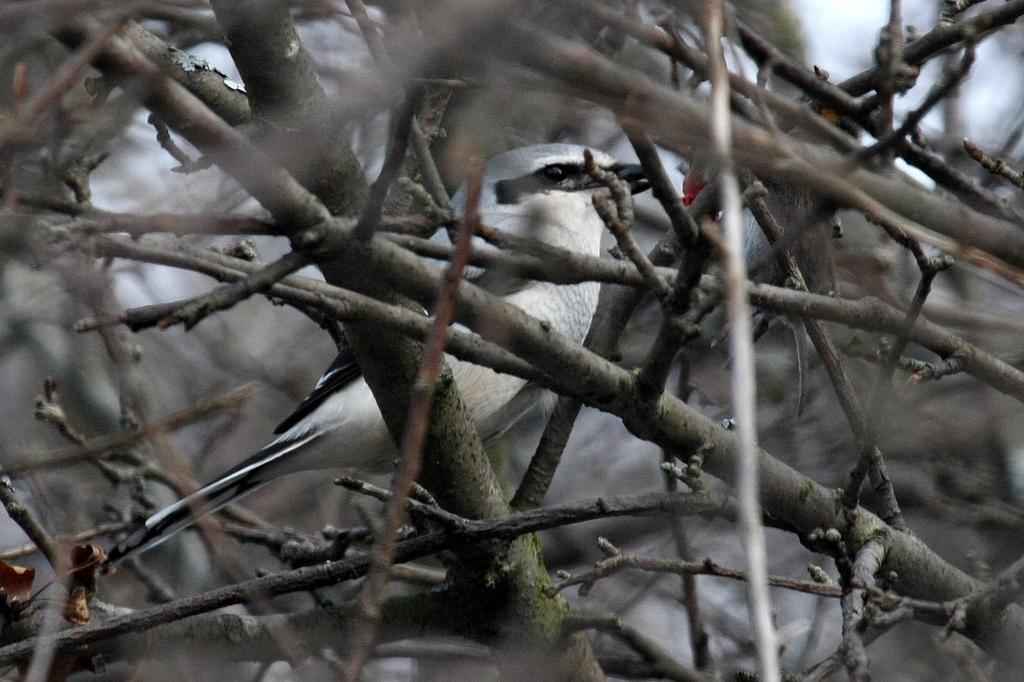Can you describe this image briefly? In this image, we can see a bird and some animal here. Here we can see so many stems and dry leaves. 